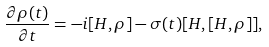<formula> <loc_0><loc_0><loc_500><loc_500>\frac { \partial \rho ( t ) } { \partial t } = - i [ H , \rho ] - \sigma ( t ) [ H , [ H , \rho ] ] ,</formula> 